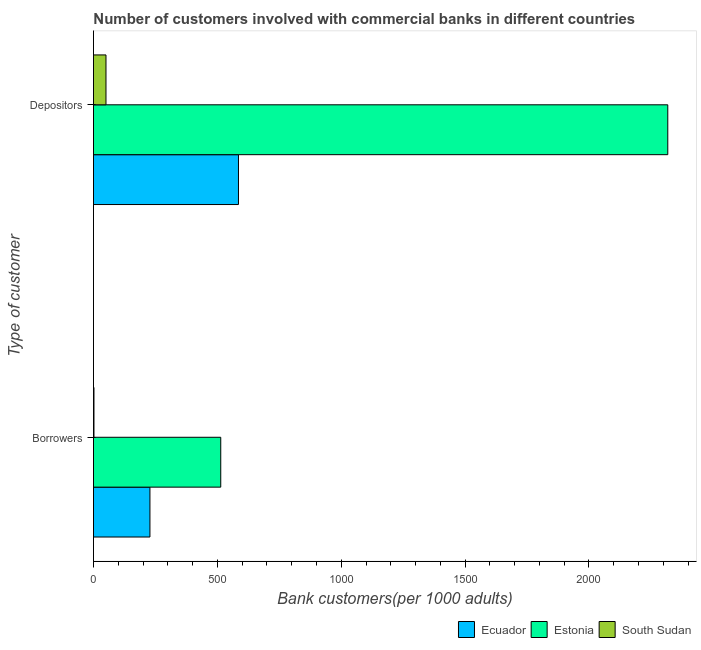How many different coloured bars are there?
Your answer should be compact. 3. How many groups of bars are there?
Offer a terse response. 2. Are the number of bars per tick equal to the number of legend labels?
Ensure brevity in your answer.  Yes. Are the number of bars on each tick of the Y-axis equal?
Your answer should be compact. Yes. How many bars are there on the 1st tick from the top?
Ensure brevity in your answer.  3. What is the label of the 1st group of bars from the top?
Provide a succinct answer. Depositors. What is the number of depositors in South Sudan?
Your response must be concise. 50.61. Across all countries, what is the maximum number of depositors?
Your response must be concise. 2318.01. Across all countries, what is the minimum number of borrowers?
Keep it short and to the point. 2.07. In which country was the number of depositors maximum?
Your answer should be very brief. Estonia. In which country was the number of borrowers minimum?
Make the answer very short. South Sudan. What is the total number of borrowers in the graph?
Ensure brevity in your answer.  743.86. What is the difference between the number of borrowers in Estonia and that in South Sudan?
Your response must be concise. 511.72. What is the difference between the number of borrowers in Estonia and the number of depositors in South Sudan?
Your answer should be very brief. 463.19. What is the average number of depositors per country?
Your answer should be very brief. 984.64. What is the difference between the number of borrowers and number of depositors in Estonia?
Offer a very short reply. -1804.22. In how many countries, is the number of borrowers greater than 2300 ?
Provide a short and direct response. 0. What is the ratio of the number of borrowers in South Sudan to that in Estonia?
Provide a succinct answer. 0. In how many countries, is the number of borrowers greater than the average number of borrowers taken over all countries?
Give a very brief answer. 1. What does the 2nd bar from the top in Depositors represents?
Offer a very short reply. Estonia. What does the 2nd bar from the bottom in Borrowers represents?
Offer a terse response. Estonia. Are the values on the major ticks of X-axis written in scientific E-notation?
Offer a very short reply. No. Does the graph contain any zero values?
Make the answer very short. No. Does the graph contain grids?
Provide a short and direct response. No. Where does the legend appear in the graph?
Make the answer very short. Bottom right. What is the title of the graph?
Offer a very short reply. Number of customers involved with commercial banks in different countries. What is the label or title of the X-axis?
Your response must be concise. Bank customers(per 1000 adults). What is the label or title of the Y-axis?
Ensure brevity in your answer.  Type of customer. What is the Bank customers(per 1000 adults) of Ecuador in Borrowers?
Provide a succinct answer. 228. What is the Bank customers(per 1000 adults) in Estonia in Borrowers?
Give a very brief answer. 513.79. What is the Bank customers(per 1000 adults) in South Sudan in Borrowers?
Keep it short and to the point. 2.07. What is the Bank customers(per 1000 adults) of Ecuador in Depositors?
Keep it short and to the point. 585.31. What is the Bank customers(per 1000 adults) in Estonia in Depositors?
Make the answer very short. 2318.01. What is the Bank customers(per 1000 adults) of South Sudan in Depositors?
Ensure brevity in your answer.  50.61. Across all Type of customer, what is the maximum Bank customers(per 1000 adults) of Ecuador?
Provide a short and direct response. 585.31. Across all Type of customer, what is the maximum Bank customers(per 1000 adults) of Estonia?
Your answer should be compact. 2318.01. Across all Type of customer, what is the maximum Bank customers(per 1000 adults) in South Sudan?
Make the answer very short. 50.61. Across all Type of customer, what is the minimum Bank customers(per 1000 adults) in Ecuador?
Your answer should be very brief. 228. Across all Type of customer, what is the minimum Bank customers(per 1000 adults) in Estonia?
Provide a short and direct response. 513.79. Across all Type of customer, what is the minimum Bank customers(per 1000 adults) of South Sudan?
Provide a short and direct response. 2.07. What is the total Bank customers(per 1000 adults) of Ecuador in the graph?
Give a very brief answer. 813.31. What is the total Bank customers(per 1000 adults) in Estonia in the graph?
Offer a very short reply. 2831.8. What is the total Bank customers(per 1000 adults) of South Sudan in the graph?
Ensure brevity in your answer.  52.68. What is the difference between the Bank customers(per 1000 adults) in Ecuador in Borrowers and that in Depositors?
Provide a succinct answer. -357.31. What is the difference between the Bank customers(per 1000 adults) in Estonia in Borrowers and that in Depositors?
Ensure brevity in your answer.  -1804.22. What is the difference between the Bank customers(per 1000 adults) of South Sudan in Borrowers and that in Depositors?
Provide a short and direct response. -48.54. What is the difference between the Bank customers(per 1000 adults) in Ecuador in Borrowers and the Bank customers(per 1000 adults) in Estonia in Depositors?
Ensure brevity in your answer.  -2090.01. What is the difference between the Bank customers(per 1000 adults) in Ecuador in Borrowers and the Bank customers(per 1000 adults) in South Sudan in Depositors?
Your answer should be compact. 177.39. What is the difference between the Bank customers(per 1000 adults) in Estonia in Borrowers and the Bank customers(per 1000 adults) in South Sudan in Depositors?
Your answer should be very brief. 463.19. What is the average Bank customers(per 1000 adults) of Ecuador per Type of customer?
Make the answer very short. 406.65. What is the average Bank customers(per 1000 adults) of Estonia per Type of customer?
Provide a short and direct response. 1415.9. What is the average Bank customers(per 1000 adults) in South Sudan per Type of customer?
Keep it short and to the point. 26.34. What is the difference between the Bank customers(per 1000 adults) of Ecuador and Bank customers(per 1000 adults) of Estonia in Borrowers?
Provide a short and direct response. -285.79. What is the difference between the Bank customers(per 1000 adults) of Ecuador and Bank customers(per 1000 adults) of South Sudan in Borrowers?
Offer a very short reply. 225.93. What is the difference between the Bank customers(per 1000 adults) of Estonia and Bank customers(per 1000 adults) of South Sudan in Borrowers?
Make the answer very short. 511.72. What is the difference between the Bank customers(per 1000 adults) in Ecuador and Bank customers(per 1000 adults) in Estonia in Depositors?
Keep it short and to the point. -1732.7. What is the difference between the Bank customers(per 1000 adults) of Ecuador and Bank customers(per 1000 adults) of South Sudan in Depositors?
Offer a terse response. 534.7. What is the difference between the Bank customers(per 1000 adults) of Estonia and Bank customers(per 1000 adults) of South Sudan in Depositors?
Make the answer very short. 2267.4. What is the ratio of the Bank customers(per 1000 adults) in Ecuador in Borrowers to that in Depositors?
Give a very brief answer. 0.39. What is the ratio of the Bank customers(per 1000 adults) in Estonia in Borrowers to that in Depositors?
Your answer should be very brief. 0.22. What is the ratio of the Bank customers(per 1000 adults) of South Sudan in Borrowers to that in Depositors?
Ensure brevity in your answer.  0.04. What is the difference between the highest and the second highest Bank customers(per 1000 adults) in Ecuador?
Offer a very short reply. 357.31. What is the difference between the highest and the second highest Bank customers(per 1000 adults) in Estonia?
Give a very brief answer. 1804.22. What is the difference between the highest and the second highest Bank customers(per 1000 adults) of South Sudan?
Offer a very short reply. 48.54. What is the difference between the highest and the lowest Bank customers(per 1000 adults) of Ecuador?
Offer a terse response. 357.31. What is the difference between the highest and the lowest Bank customers(per 1000 adults) in Estonia?
Your answer should be very brief. 1804.22. What is the difference between the highest and the lowest Bank customers(per 1000 adults) in South Sudan?
Provide a succinct answer. 48.54. 